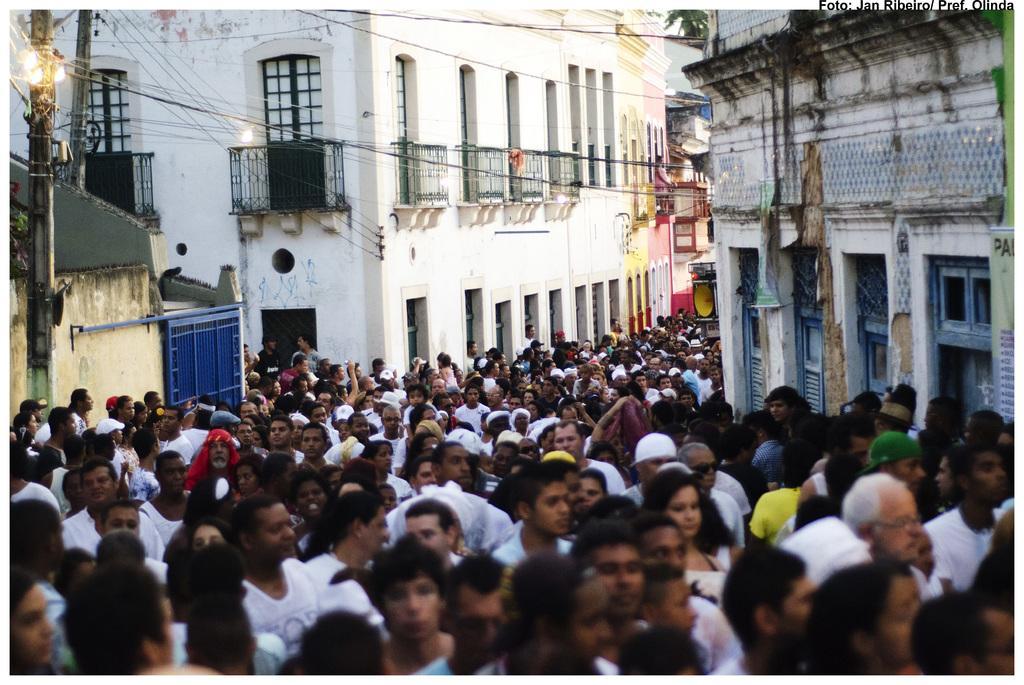Can you describe this image briefly? At the bottom of the image there is crowd. In the background there are buildings, wires, poles, light, tree and a gate. 